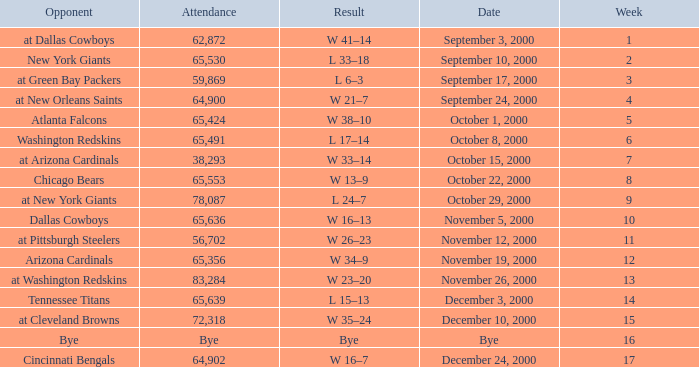What was the attendance when the Cincinnati Bengals were the opponents? 64902.0. 